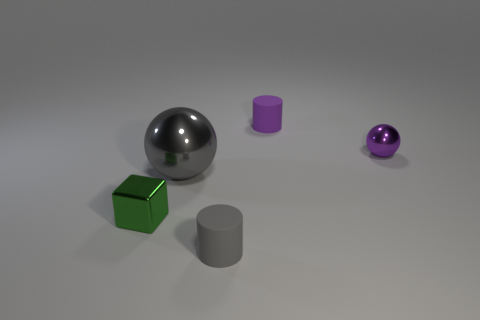There is a purple shiny sphere; does it have the same size as the gray metallic ball that is behind the small gray matte thing? Upon closer inspection, the purple shiny sphere appears to be smaller in diameter than the gray metallic ball. Perspective plays a role here; objects closer to us seem larger than those farther away. However, even accounting for this, the purple sphere is indeed smaller when comparing the visible proportion to the surroundings and the relative size of objects we know are uniform, like the small gray matte cylinder. 